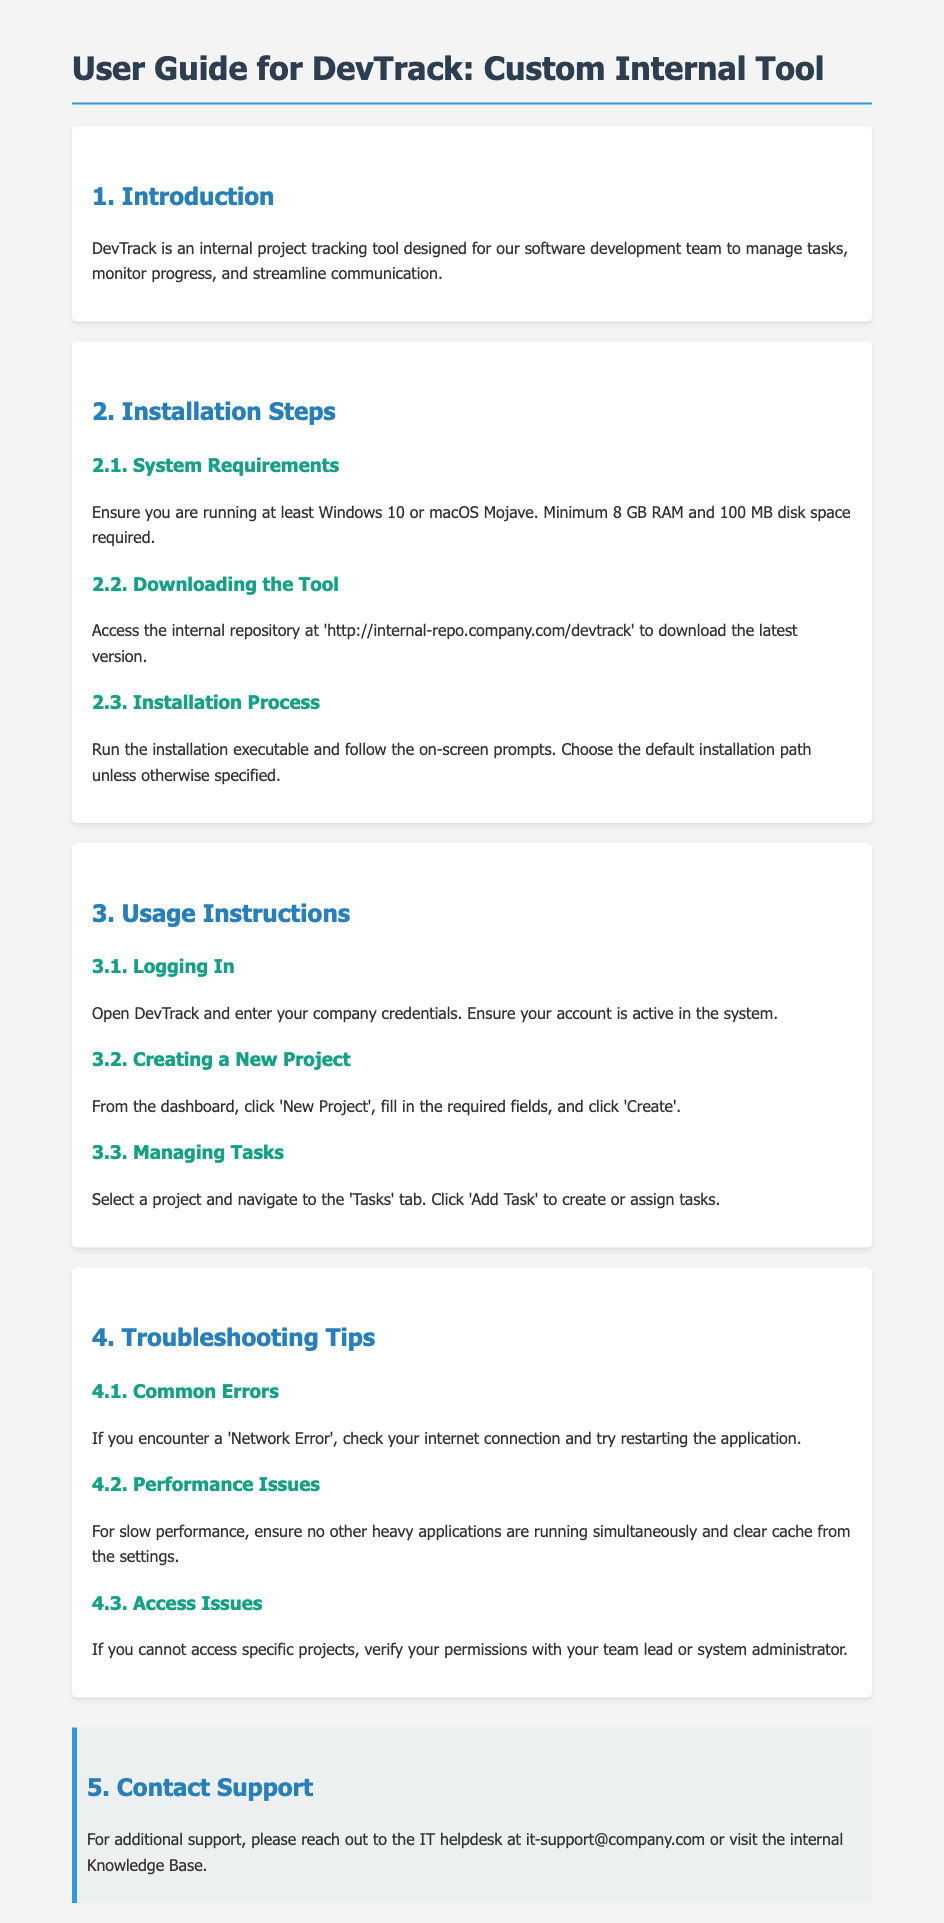What is the minimum RAM requirement? The document states that the minimum RAM requirement is 8 GB.
Answer: 8 GB Where can you download DevTrack? The document mentions to access the internal repository at 'http://internal-repo.company.com/devtrack' for downloading the tool.
Answer: http://internal-repo.company.com/devtrack What should you do if you encounter a 'Network Error'? According to the troubleshooting tips, you should check your internet connection and try restarting the application.
Answer: Check your internet connection Which operating systems are supported? The system requirements specify that you should be running at least Windows 10 or macOS Mojave.
Answer: Windows 10 or macOS Mojave What is the process to create a new project? The document states that you need to click 'New Project', fill in the required fields, and click 'Create' from the dashboard.
Answer: Click 'New Project' What should you verify if you cannot access specific projects? The document advises verifying your permissions with your team lead or system administrator if access issues occur.
Answer: Verify your permissions What is the contact email for IT support? The document provides the contact email for IT support as it-support@company.com.
Answer: it-support@company.com How do you manage tasks in a project? You should select a project, navigate to the 'Tasks' tab, and click 'Add Task' to manage tasks according to the usage instructions.
Answer: Navigate to the 'Tasks' tab What is the recommended action for slow performance? The document mentions ensuring no other heavy applications are running and clearing cache from the settings.
Answer: Clear cache from the settings 